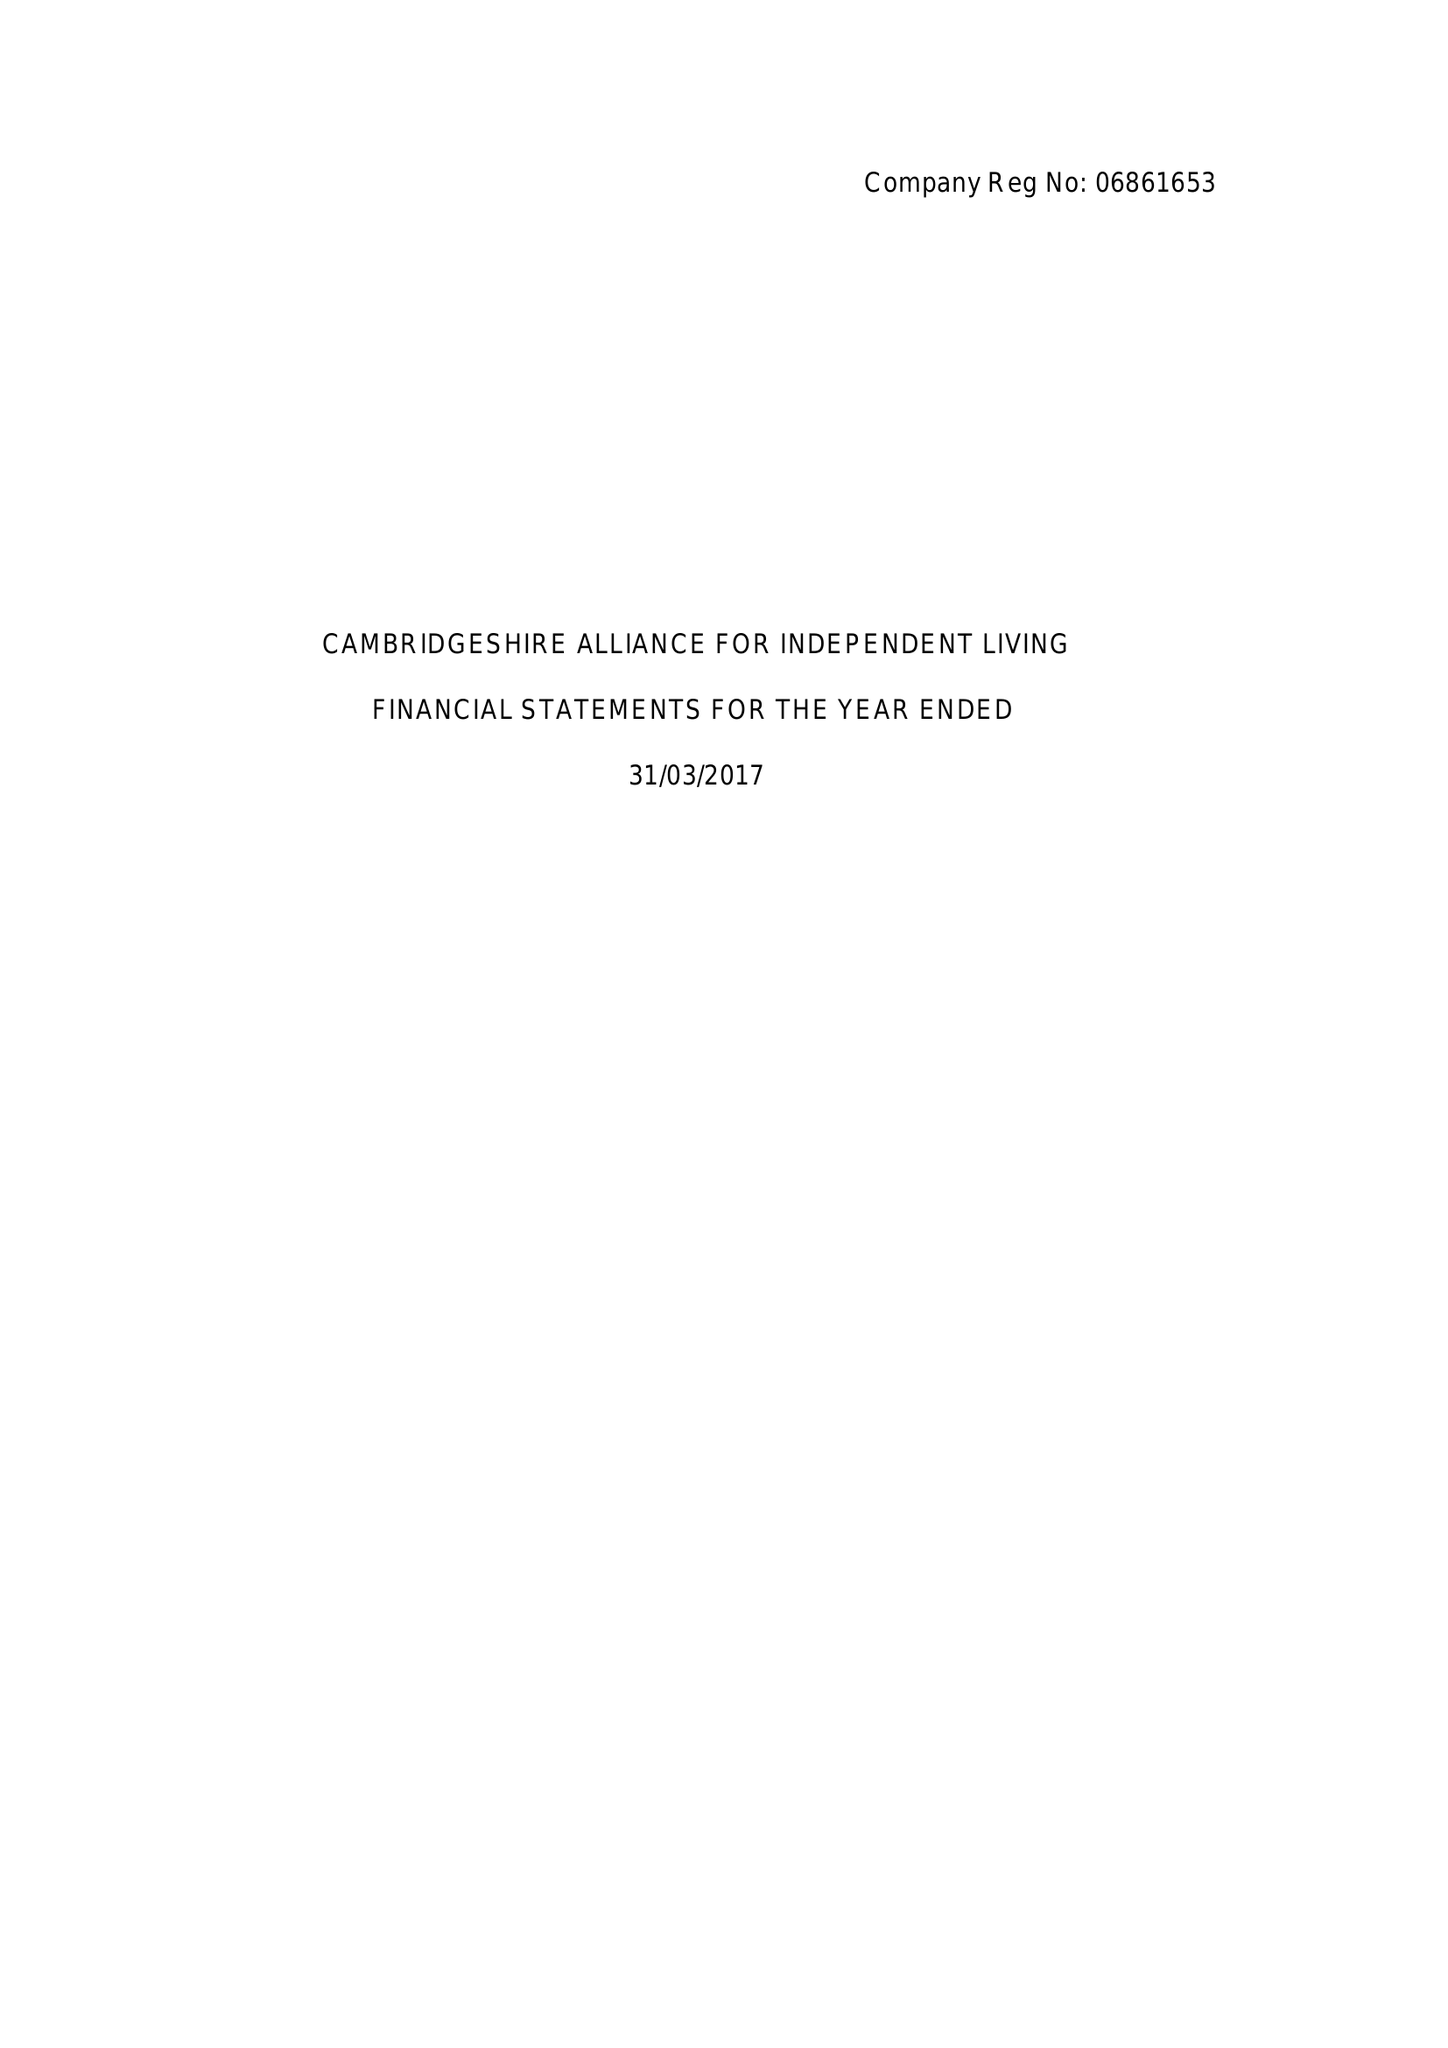What is the value for the address__postcode?
Answer the question using a single word or phrase. CB4 1UN 